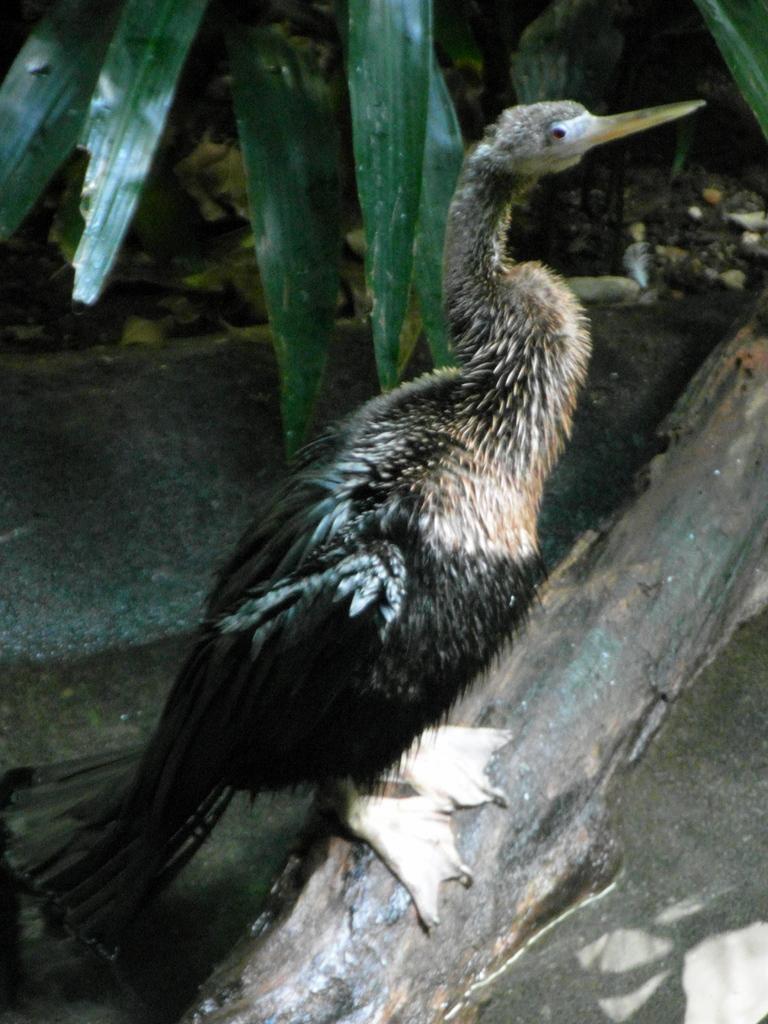Could you give a brief overview of what you see in this image? In the image we can see the bird on the wooden log. Here we can see water, sand and leaves. 